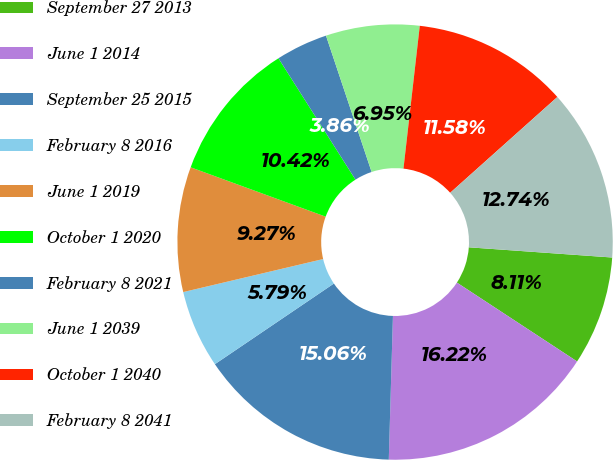Convert chart. <chart><loc_0><loc_0><loc_500><loc_500><pie_chart><fcel>September 27 2013<fcel>June 1 2014<fcel>September 25 2015<fcel>February 8 2016<fcel>June 1 2019<fcel>October 1 2020<fcel>February 8 2021<fcel>June 1 2039<fcel>October 1 2040<fcel>February 8 2041<nl><fcel>8.11%<fcel>16.22%<fcel>15.06%<fcel>5.79%<fcel>9.27%<fcel>10.42%<fcel>3.86%<fcel>6.95%<fcel>11.58%<fcel>12.74%<nl></chart> 